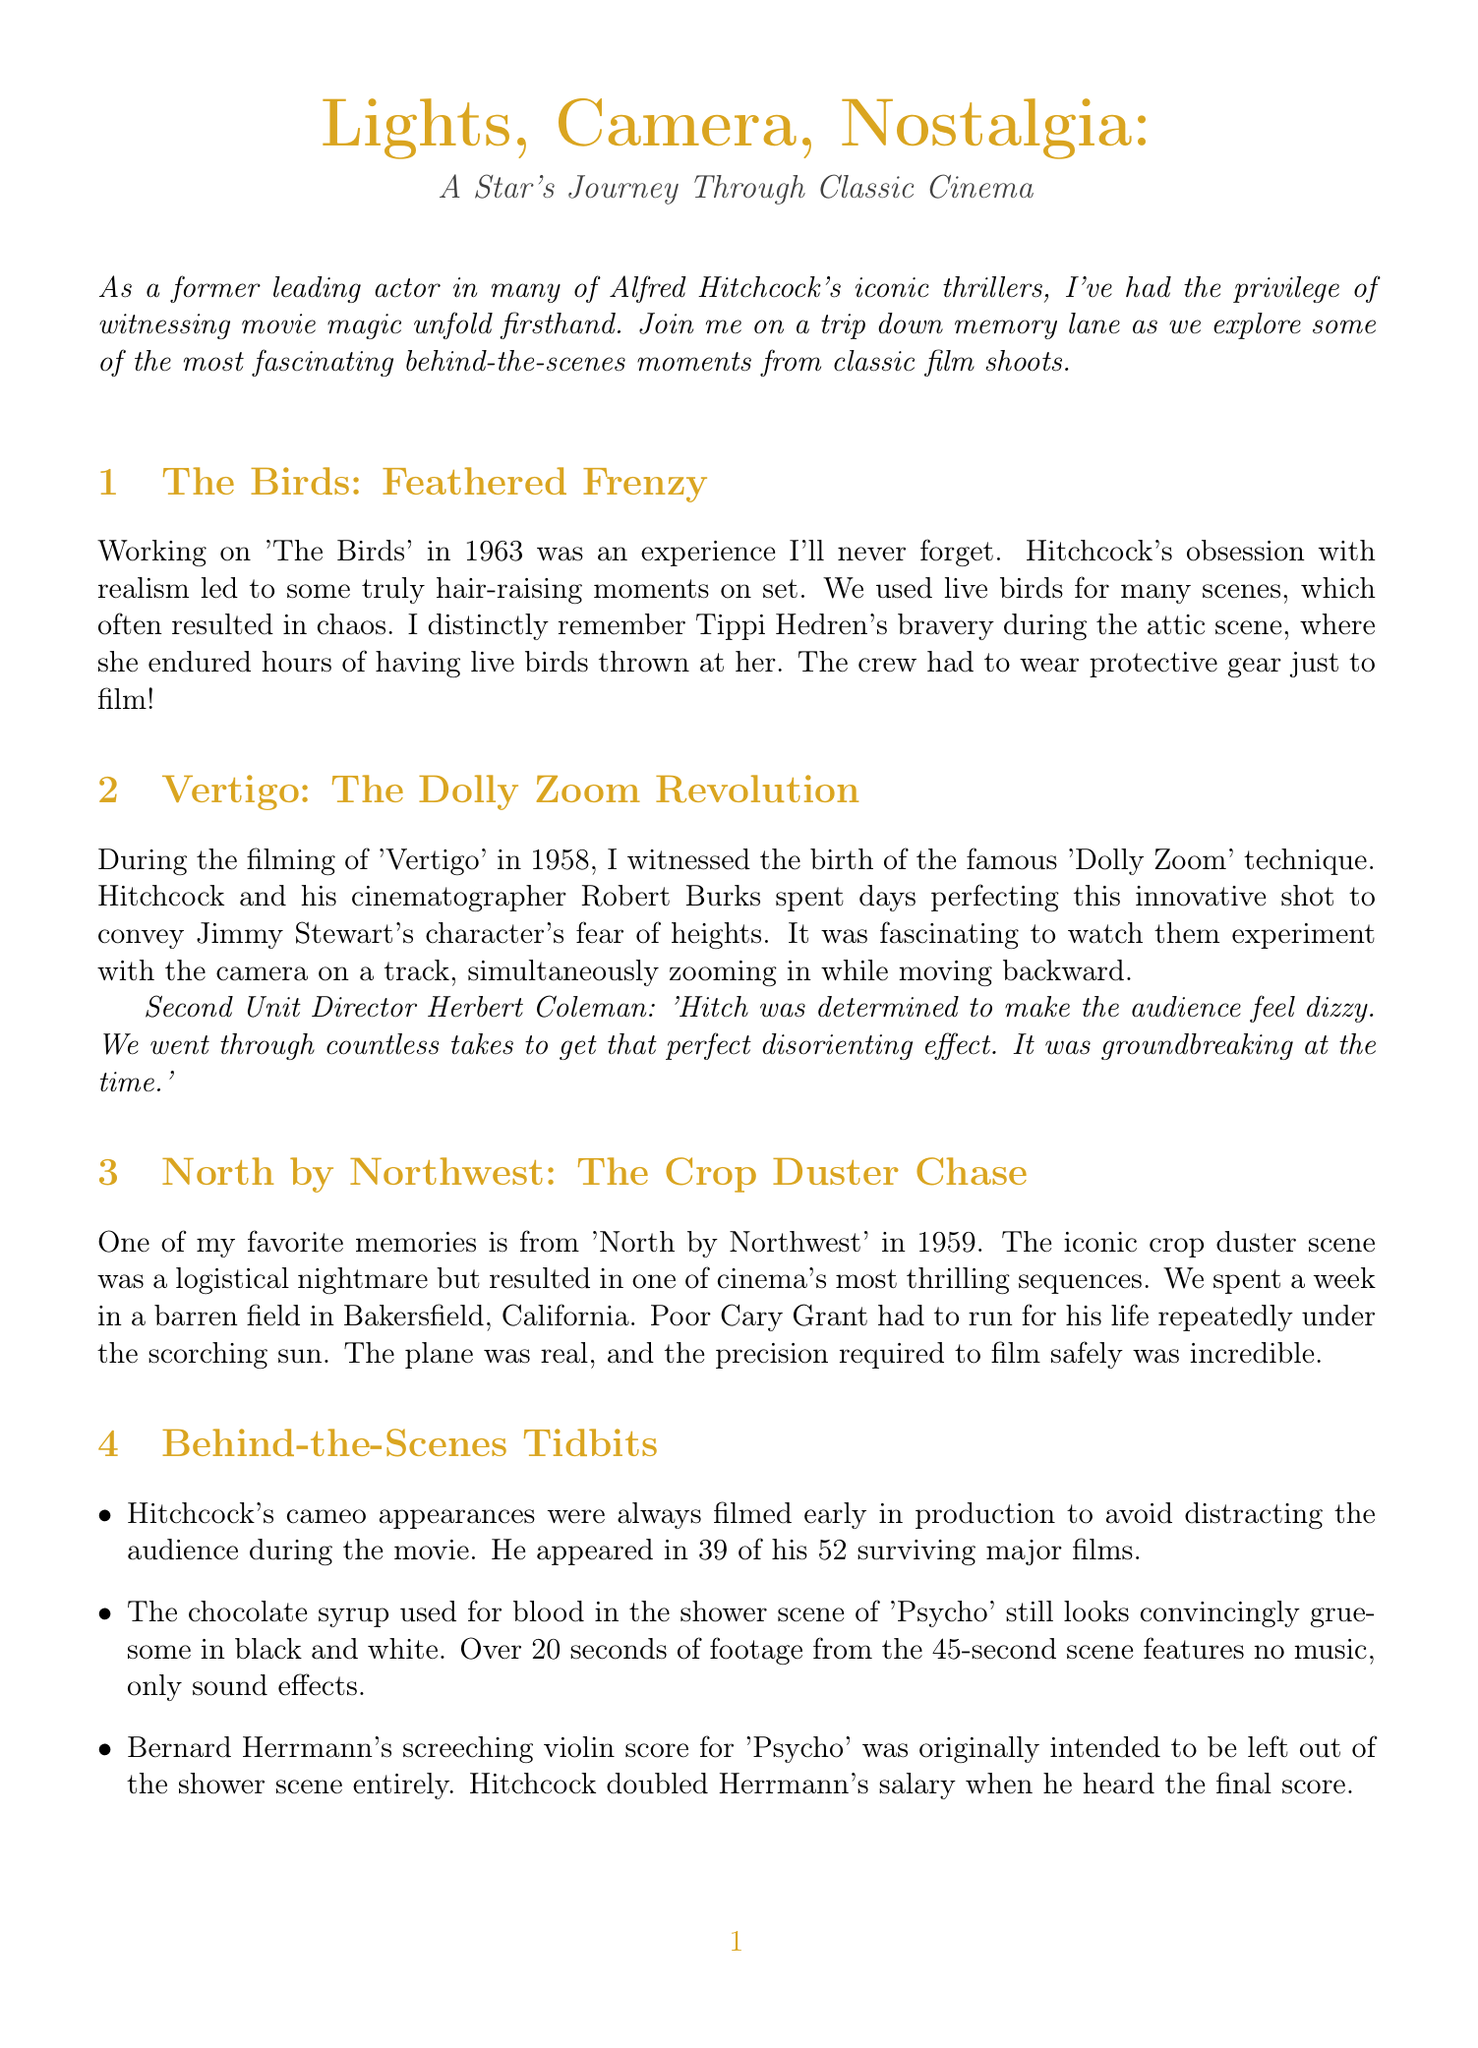What year was "The Birds" filmed? The document states that "The Birds" was filmed in 1963.
Answer: 1963 Who was the cinematographer for "Vertigo"? According to the document, Robert Burks was the cinematographer for "Vertigo".
Answer: Robert Burks What technique was perfected during the filming of "Vertigo"? The document mentions the famous "Dolly Zoom" technique was perfected during "Vertigo".
Answer: Dolly Zoom How many films did Hitchcock appear in? The document notes that Hitchcock appeared in 39 out of his 52 surviving major films.
Answer: 39 What was used for blood in the shower scene of "Psycho"? The document describes that chocolate syrup was used for blood in "Psycho".
Answer: Chocolate syrup What did Cary Grant have to do in the crop duster scene of "North by Northwest"? The document indicates that Cary Grant had to run for his life in the crop duster scene.
Answer: Run for his life What year was "North by Northwest" released? The document states that "North by Northwest" was released in 1959.
Answer: 1959 Who described the taking of countless takes for "Vertigo"? The document mentions Second Unit Director Herbert Coleman discussed the countless takes for "Vertigo".
Answer: Herbert Coleman 